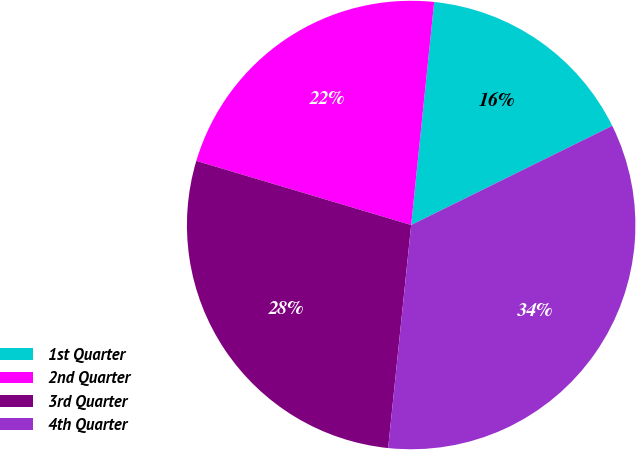<chart> <loc_0><loc_0><loc_500><loc_500><pie_chart><fcel>1st Quarter<fcel>2nd Quarter<fcel>3rd Quarter<fcel>4th Quarter<nl><fcel>16.07%<fcel>22.02%<fcel>27.98%<fcel>33.93%<nl></chart> 